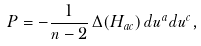Convert formula to latex. <formula><loc_0><loc_0><loc_500><loc_500>P = - \frac { 1 } { n - 2 } \, \Delta ( H _ { a c } ) \, d u ^ { a } d u ^ { c } ,</formula> 